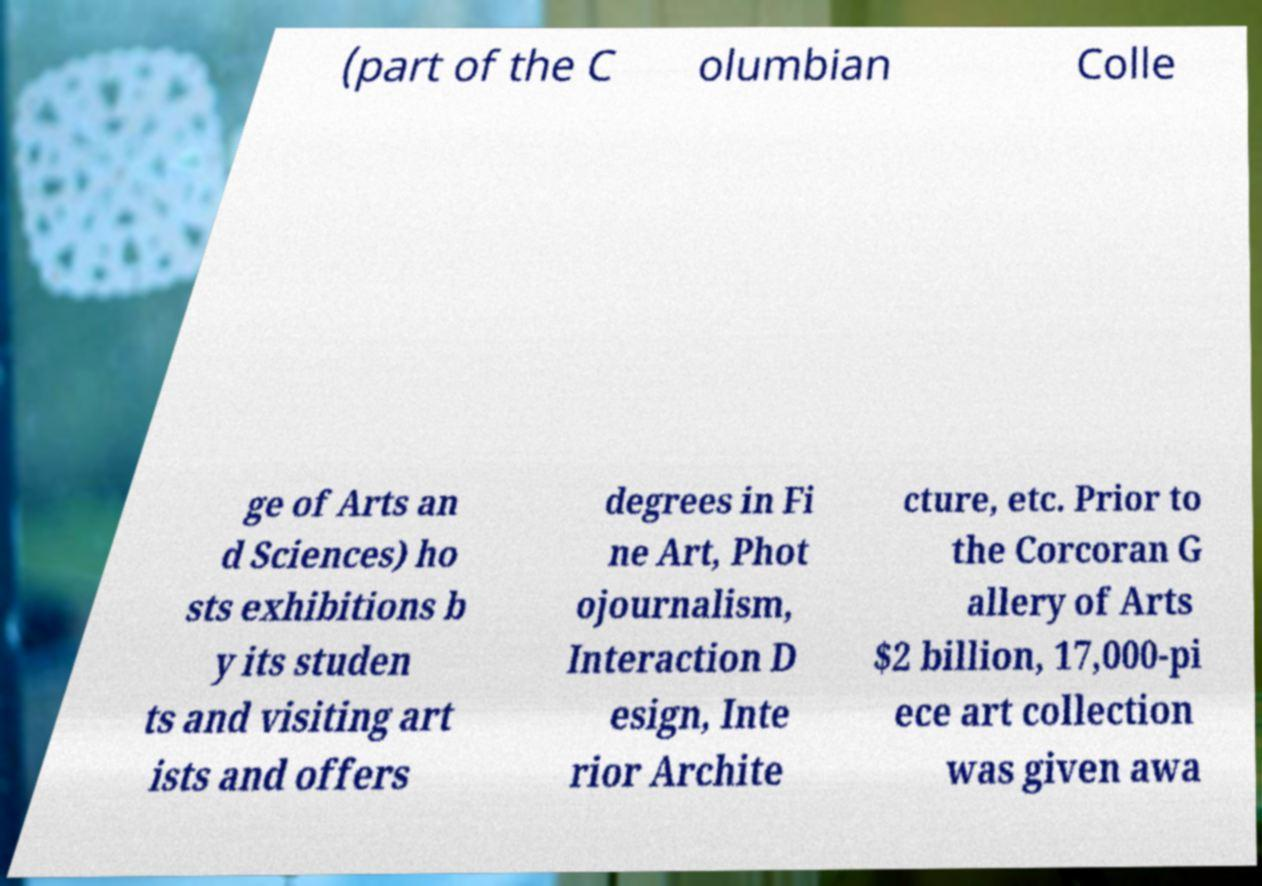Could you extract and type out the text from this image? (part of the C olumbian Colle ge of Arts an d Sciences) ho sts exhibitions b y its studen ts and visiting art ists and offers degrees in Fi ne Art, Phot ojournalism, Interaction D esign, Inte rior Archite cture, etc. Prior to the Corcoran G allery of Arts $2 billion, 17,000-pi ece art collection was given awa 